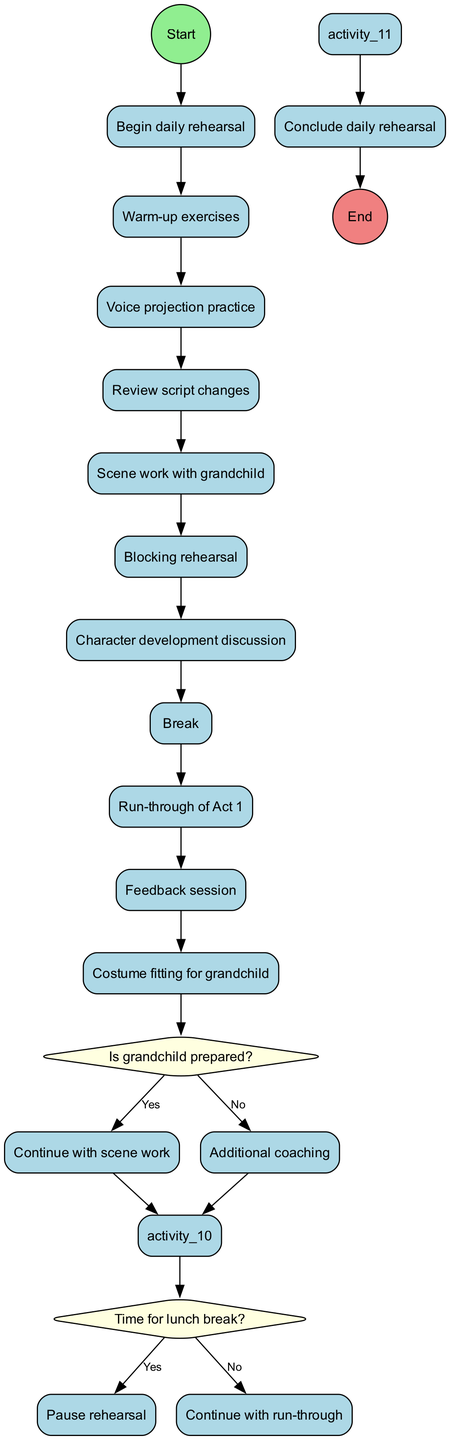What is the first activity listed in the diagram? The first activity follows the start node and is listed as "Warm-up exercises".
Answer: Warm-up exercises How many activities are included in the diagram? There are ten distinct activities outlined in the diagram.
Answer: 10 What decision is made after working on the scene with the grandchild? The decision made is based on whether the grandchild is prepared, leading to either continuing with scene work or providing additional coaching.
Answer: Is grandchild prepared? Which activity comes directly after the feedback session? After the feedback session, the next activity listed is "Costume fitting for grandchild".
Answer: Costume fitting for grandchild What happens if the grandchild is not prepared? If the grandchild is not prepared, the flow indicates that additional coaching will take place.
Answer: Additional coaching Is there a break included in the rehearsal schedule? Yes, there is a "Break" activity included in the list of activities.
Answer: Yes How many decisions are made during the rehearsal according to the diagram? Two decisions are present in the diagram concerning the grandchild's preparedness and the timing for lunch break.
Answer: 2 What is the final node in the diagram? The end node signifies the conclusion of the daily rehearsal, labeled as "Conclude daily rehearsal".
Answer: Conclude daily rehearsal What activity follows the "Blocking rehearsal"? The activity that follows "Blocking rehearsal" is the "Character development discussion".
Answer: Character development discussion 